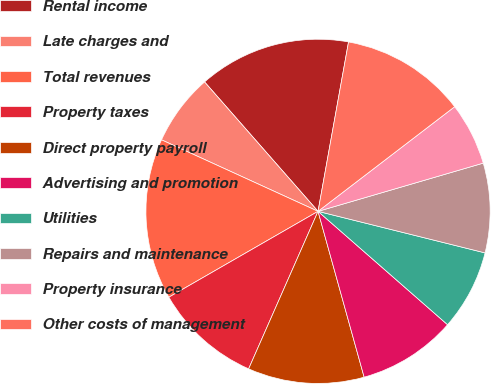<chart> <loc_0><loc_0><loc_500><loc_500><pie_chart><fcel>Rental income<fcel>Late charges and<fcel>Total revenues<fcel>Property taxes<fcel>Direct property payroll<fcel>Advertising and promotion<fcel>Utilities<fcel>Repairs and maintenance<fcel>Property insurance<fcel>Other costs of management<nl><fcel>14.29%<fcel>6.72%<fcel>15.13%<fcel>10.08%<fcel>10.92%<fcel>9.24%<fcel>7.56%<fcel>8.4%<fcel>5.88%<fcel>11.76%<nl></chart> 